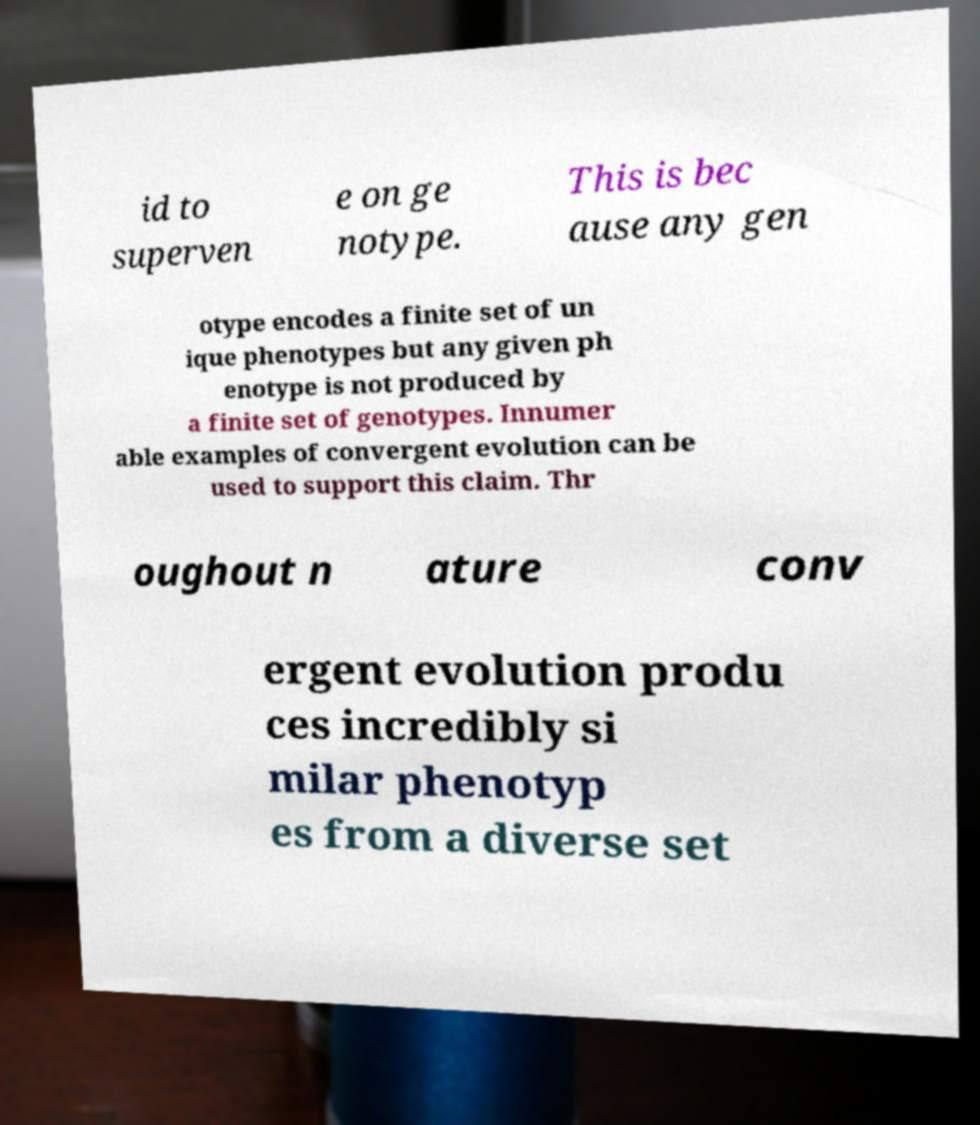What messages or text are displayed in this image? I need them in a readable, typed format. id to superven e on ge notype. This is bec ause any gen otype encodes a finite set of un ique phenotypes but any given ph enotype is not produced by a finite set of genotypes. Innumer able examples of convergent evolution can be used to support this claim. Thr oughout n ature conv ergent evolution produ ces incredibly si milar phenotyp es from a diverse set 